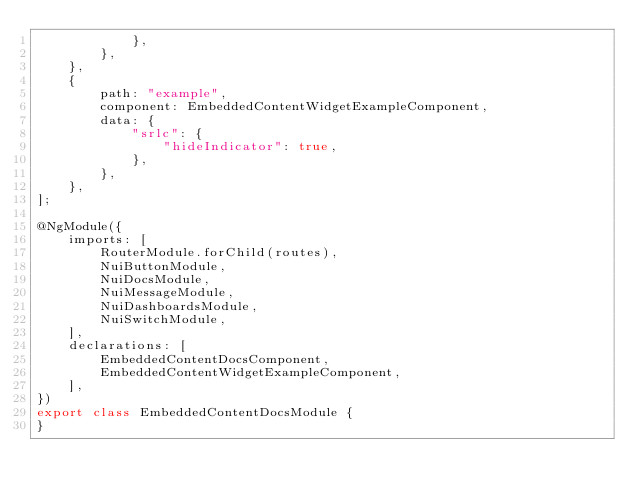<code> <loc_0><loc_0><loc_500><loc_500><_TypeScript_>            },
        },
    },
    {
        path: "example",
        component: EmbeddedContentWidgetExampleComponent,
        data: {
            "srlc": {
                "hideIndicator": true,
            },
        },
    },
];

@NgModule({
    imports: [
        RouterModule.forChild(routes),
        NuiButtonModule,
        NuiDocsModule,
        NuiMessageModule,
        NuiDashboardsModule,
        NuiSwitchModule,
    ],
    declarations: [
        EmbeddedContentDocsComponent,
        EmbeddedContentWidgetExampleComponent,
    ],
})
export class EmbeddedContentDocsModule {
}
</code> 